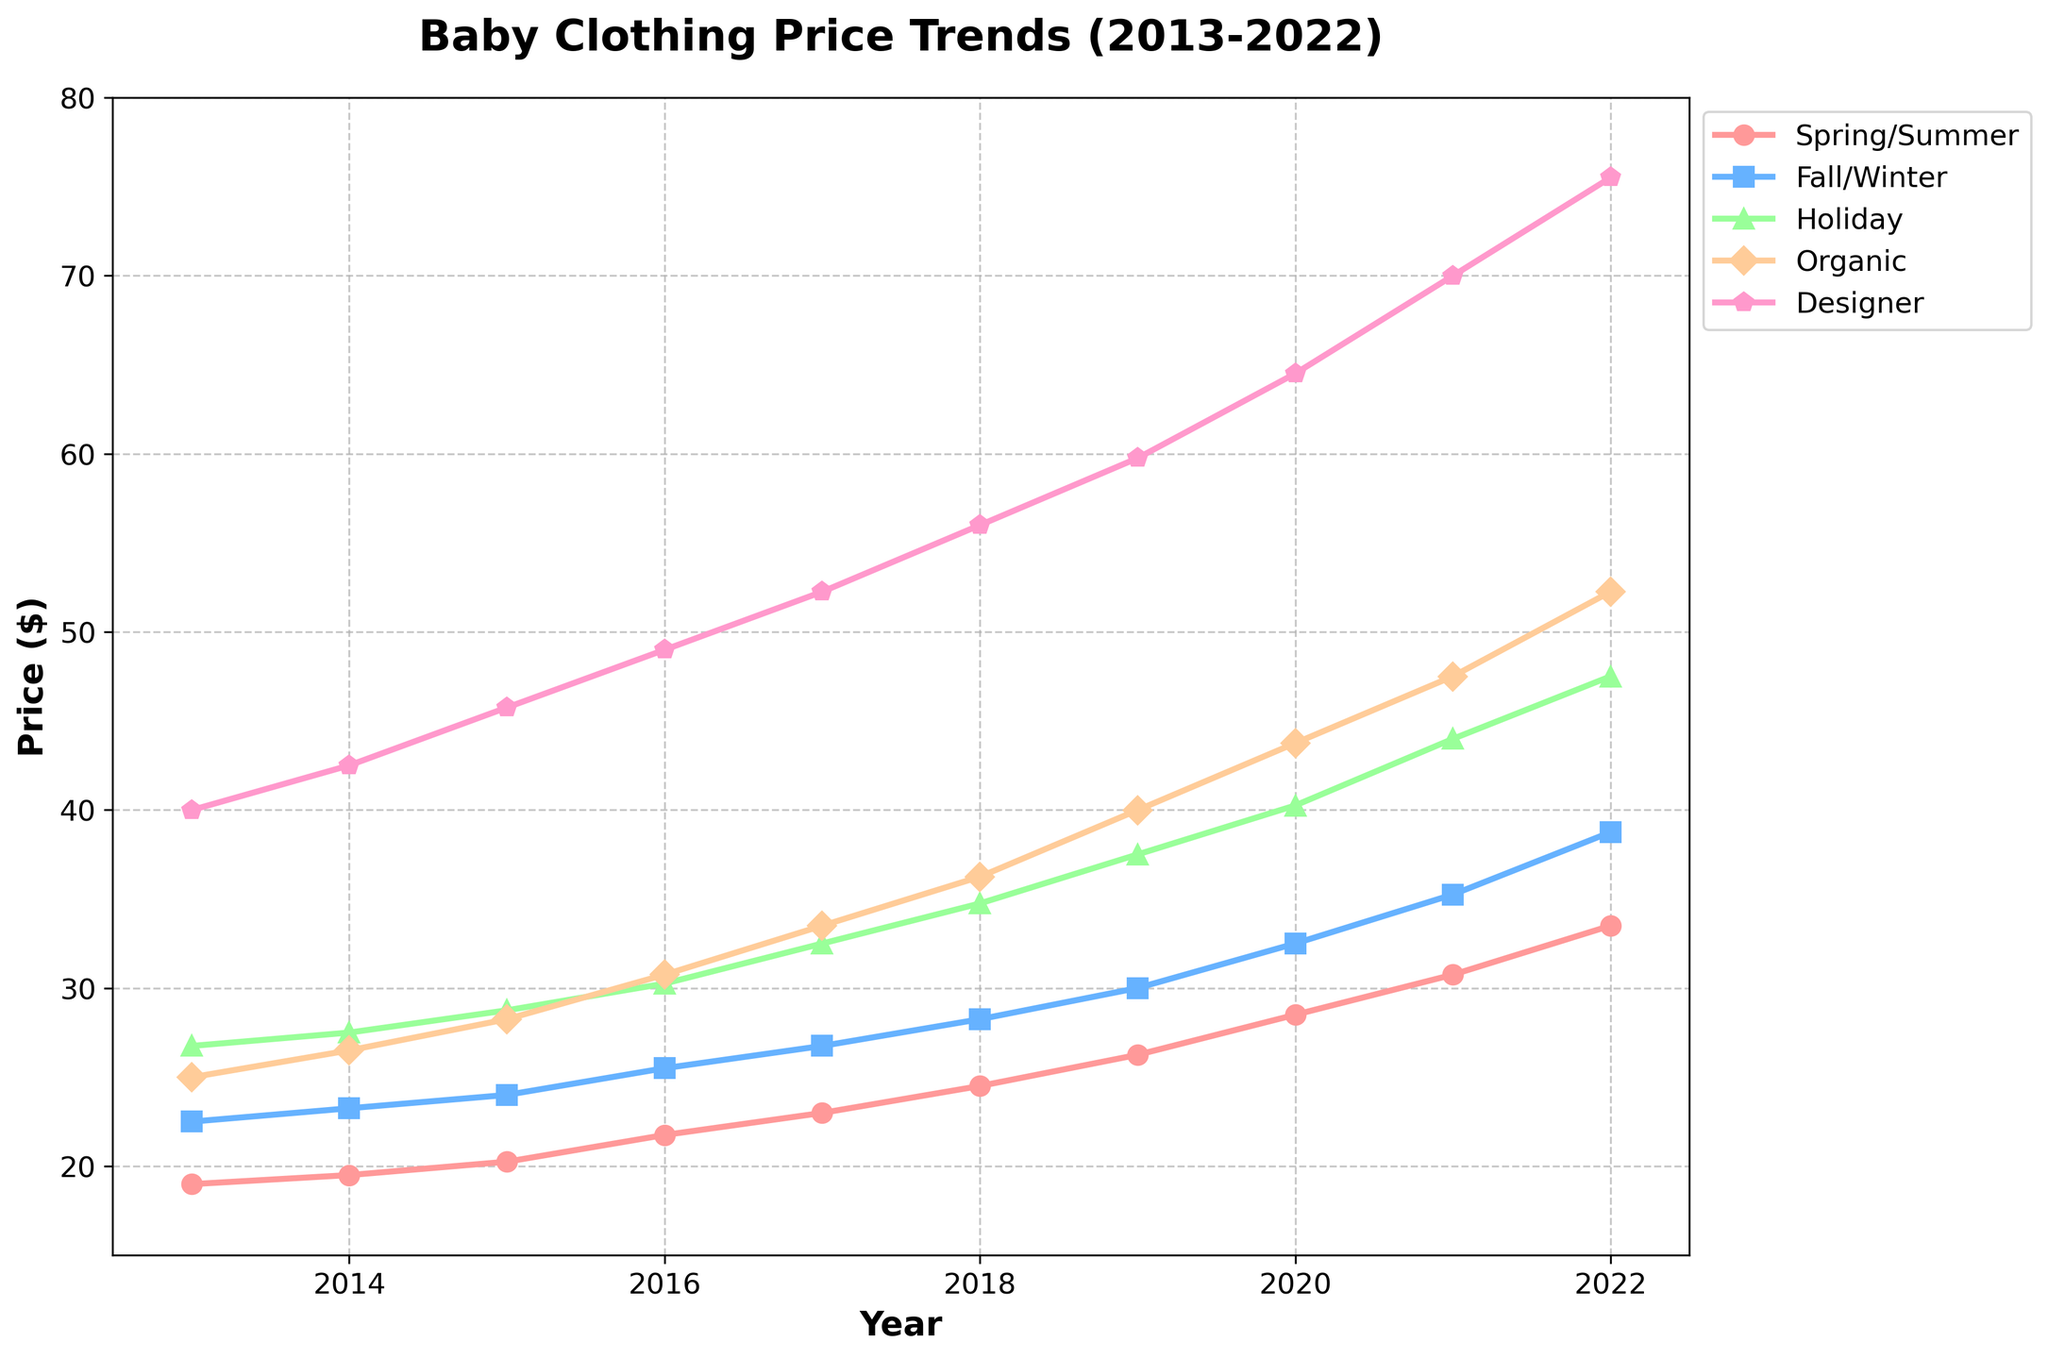What are the trends in Spring/Summer and Fall/Winter clothing prices from 2013 to 2022? Spring/Summer prices have an upward trend starting at $18.99 in 2013 and ending at $33.50 in 2022. Fall/Winter prices also increase, starting at $22.50 in 2013 and reaching $38.75 in 2022.
Answer: Both show an upward trend Which collection experienced the highest price increase from 2013 to 2022? To find out, we calculate the difference in prices from 2013 to 2022 for each collection: Spring/Summer ($33.50 - $18.99 = $14.51), Fall/Winter ($38.75 - $22.50 = $16.25), Holiday ($47.50 - $26.75 = $20.75), Organic ($52.25 - $24.99 = $27.26), Designer ($75.50 - $39.99 = $35.51). Designer had the highest increase.
Answer: Designer Between 2017 and 2018, which collection had the smallest price increase? Calculate the price differences between 2017 and 2018 for each collection: Spring/Summer ($24.50 - $22.99 = $1.51), Fall/Winter ($28.25 - $26.75 = $1.50), Holiday ($34.75 - $32.50 = $2.25), Organic ($36.25 - $33.50 = $2.75), Designer ($55.99 - $52.25 = $3.74). Fall/Winter had the smallest increase.
Answer: Fall/Winter What is the average price of Organic clothing from 2013 to 2022? Sum the Organic prices for all years and divide by the number of years: ($24.99 + $26.50 + $28.25 + $30.75 + $33.50 + $36.25 + $39.99 + $43.75 + $47.50 + $52.25) / 10 = $36.37.
Answer: $36.37 How does the price of Designer clothing in 2020 compare to that in 2016? The price of Designer clothing in 2020 is $64.50, and in 2016 it is $48.99. $64.50 - $48.99 = $15.51, so the price increased by $15.51 from 2016 to 2020.
Answer: Increased by $15.51 What is the rate of increase (%) in the price of Holiday clothing from 2013 to 2022? Calculate the percentage increase: (Final Value - Initial Value) / Initial Value * 100 = ($47.50 - $26.75) / $26.75 * 100 ≈ 77.57%.
Answer: 77.57% Compare the prices of Spring/Summer and Holiday collections in 2019. Which is higher and by how much? The price for Spring/Summer in 2019 is $26.25 and for Holiday is $37.50. $37.50 - $26.25 = $11.25, so the Holiday collection is $11.25 higher.
Answer: Holiday by $11.25 In which year did Spring/Summer collection see the biggest year-to-year price increase? Find the differences between consecutive years: 
2014: $19.50 - $18.99 = $0.51,
2015: $20.25 - $19.50 = $0.75,
2016: $21.75 - $20.25 = $1.50, 
2017: $22.99 - $21.75 = $1.24, 
2018: $24.50 - $22.99 = $1.51, 
2019: $26.25 - $24.50 = $1.75, 
2020: $28.50 - $26.25 = $2.25, 
2021: $30.75 - $28.50 = $2.25, 
2022: $33.50 - $30.75 = $2.75. 
The year with the biggest increase is 2022.
Answer: 2022 From 2018 to 2020, which collection had the most consistent year-to-year price changes? Calculate the differences for each collection: 
Spring/Summer: ($26.25 - $24.50 = $1.75), ($28.50 - $26.25 = $2.25),
Fall/Winter: ($30.00 - $28.25 = $1.75), ($32.50 - $30.00 = $2.50),
Holiday: ($37.50 - $34.75 = $2.75), ($40.25 - $37.50 = $2.75),
Organic: ($39.99 - $36.25 = $3.74), ($43.75 - $39.99 = $3.76),
Designer: ($59.75 - $55.99 = $3.76), ($64.50 - $59.75 = $4.75). 
Holiday had the most consistent changes of $2.75 each year.
Answer: Holiday How does the price trend for Designer baby clothing compare with Organic baby clothing over the decade? Both have an increasing trend, but Designer baby clothing has a steeper trend compared to Organic.
Answer: Steeper increase for Designer 